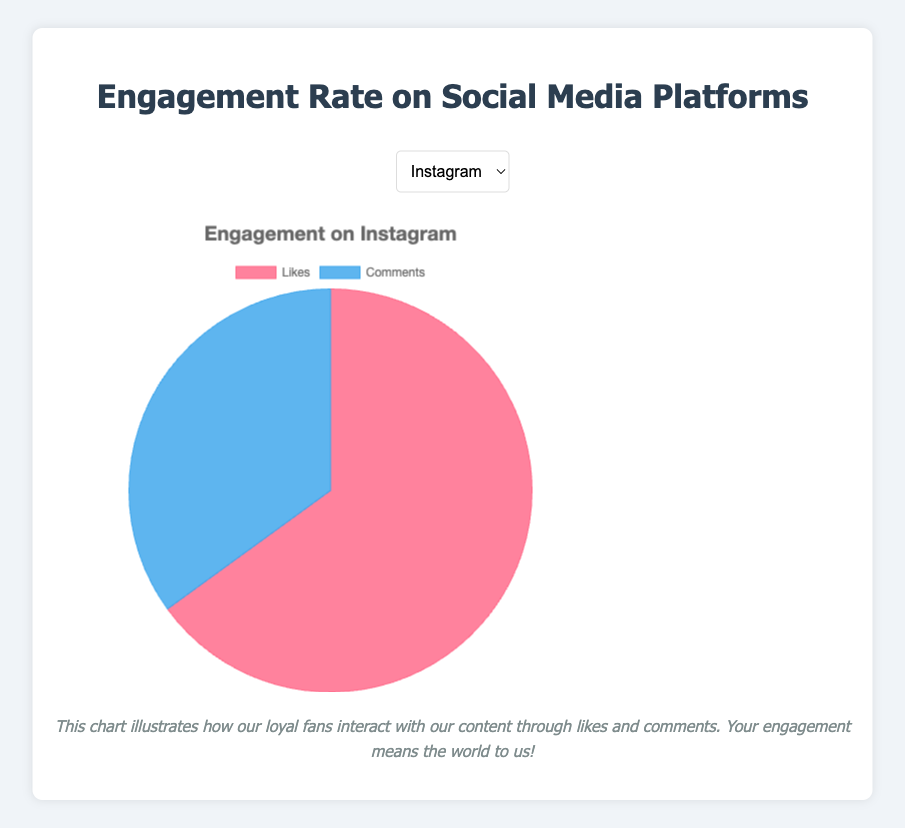Which platform has the highest percentage of likes? By checking the percentages of likes across all platforms, Twitter has the highest likes percentage at 85%.
Answer: Twitter Which platform has the closest likes percentage to Instagram? Instagram has a likes percentage of 65%. Among the other platforms, YouTube is closest with a likes percentage of 60%.
Answer: YouTube How much higher is the comments percentage on YouTube compared to Twitter? The comments percentage on YouTube is 40%, and on Twitter, it is 15%. The difference is 40% - 15% = 25%.
Answer: 25% Are there more comments on Facebook or LinkedIn? By checking the comments percentages, Facebook has 25% comments while LinkedIn has 30%. Therefore, LinkedIn has more comments.
Answer: LinkedIn What is the average likes percentage of Instagram and LinkedIn? The likes percentages for Instagram and LinkedIn are 65% and 70%, respectively. The average is (65% + 70%) / 2 = 67.5%.
Answer: 67.5% Which platform has the greatest difference between likes and comments? Twitter has the most significant difference. The likes percentage is 85% and comments is 15%, resulting in a difference of 85% - 15% = 70%.
Answer: Twitter On which platform is the engagement more balanced (smallest difference between likes and comments)? YouTube has the smallest difference. The percentages are 60% for likes and 40% for comments, resulting in a difference of 60% - 40% = 20%.
Answer: YouTube What is the combined likes percentage of Facebook and Twitter? Facebook has a likes percentage of 75% and Twitter has 85%. The combined likes percentage is 75% + 85% = 160%.
Answer: 160% Is the likes percentage on LinkedIn greater than or equal to that on Instagram? LinkedIn has a likes percentage of 70%, which is greater than Instagram's 65%.
Answer: Yes Which platform has a higher percentage of likes: Facebook or Instagram? Facebook has a likes percentage of 75%, while Instagram has 65%. Therefore, Facebook has a higher percentage of likes.
Answer: Facebook 